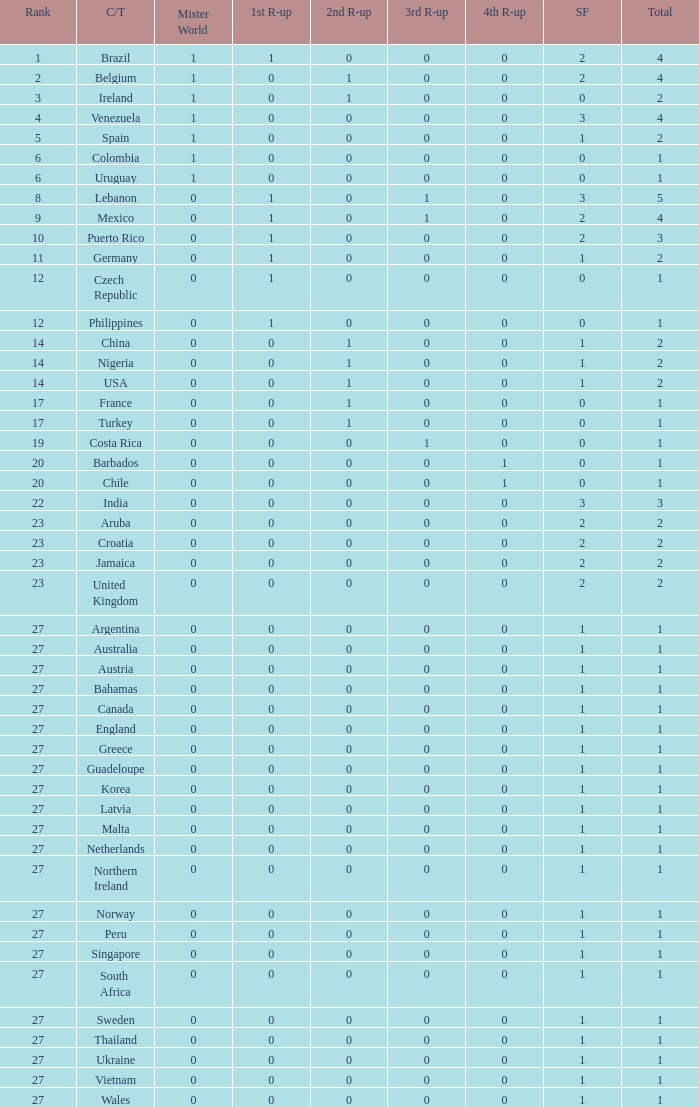How many 3rd runner up values does Turkey have? 1.0. 